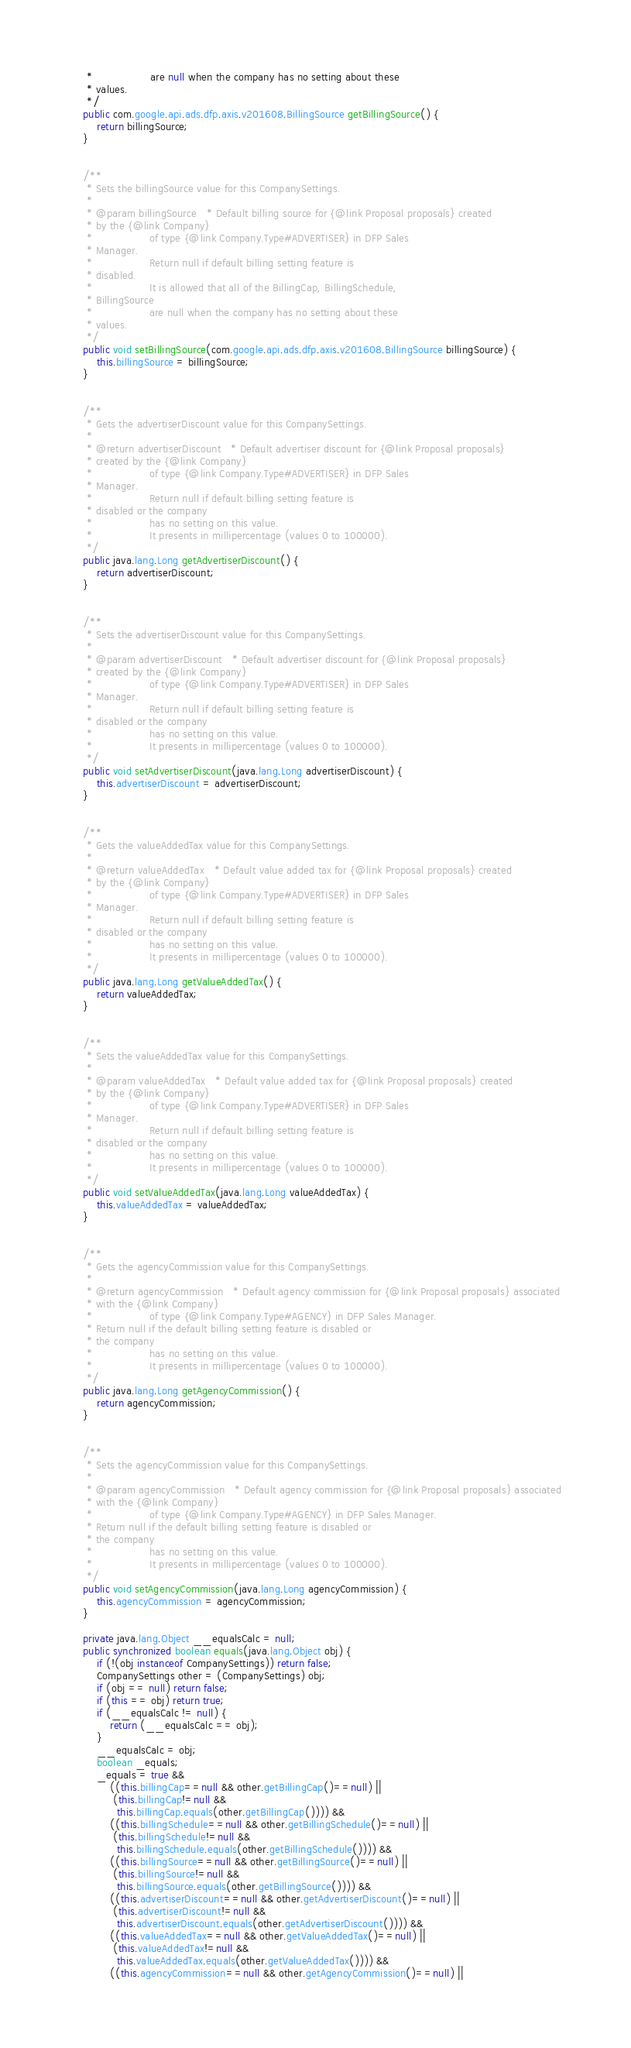Convert code to text. <code><loc_0><loc_0><loc_500><loc_500><_Java_>     *                 are null when the company has no setting about these
     * values.
     */
    public com.google.api.ads.dfp.axis.v201608.BillingSource getBillingSource() {
        return billingSource;
    }


    /**
     * Sets the billingSource value for this CompanySettings.
     * 
     * @param billingSource   * Default billing source for {@link Proposal proposals} created
     * by the {@link Company}
     *                 of type {@link Company.Type#ADVERTISER} in DFP Sales
     * Manager.
     *                 Return null if default billing setting feature is
     * disabled.
     *                 It is allowed that all of the BillingCap, BillingSchedule,
     * BillingSource
     *                 are null when the company has no setting about these
     * values.
     */
    public void setBillingSource(com.google.api.ads.dfp.axis.v201608.BillingSource billingSource) {
        this.billingSource = billingSource;
    }


    /**
     * Gets the advertiserDiscount value for this CompanySettings.
     * 
     * @return advertiserDiscount   * Default advertiser discount for {@link Proposal proposals}
     * created by the {@link Company}
     *                 of type {@link Company.Type#ADVERTISER} in DFP Sales
     * Manager.
     *                 Return null if default billing setting feature is
     * disabled or the company
     *                 has no setting on this value.
     *                 It presents in millipercentage (values 0 to 100000).
     */
    public java.lang.Long getAdvertiserDiscount() {
        return advertiserDiscount;
    }


    /**
     * Sets the advertiserDiscount value for this CompanySettings.
     * 
     * @param advertiserDiscount   * Default advertiser discount for {@link Proposal proposals}
     * created by the {@link Company}
     *                 of type {@link Company.Type#ADVERTISER} in DFP Sales
     * Manager.
     *                 Return null if default billing setting feature is
     * disabled or the company
     *                 has no setting on this value.
     *                 It presents in millipercentage (values 0 to 100000).
     */
    public void setAdvertiserDiscount(java.lang.Long advertiserDiscount) {
        this.advertiserDiscount = advertiserDiscount;
    }


    /**
     * Gets the valueAddedTax value for this CompanySettings.
     * 
     * @return valueAddedTax   * Default value added tax for {@link Proposal proposals} created
     * by the {@link Company}
     *                 of type {@link Company.Type#ADVERTISER} in DFP Sales
     * Manager.
     *                 Return null if default billing setting feature is
     * disabled or the company
     *                 has no setting on this value.
     *                 It presents in millipercentage (values 0 to 100000).
     */
    public java.lang.Long getValueAddedTax() {
        return valueAddedTax;
    }


    /**
     * Sets the valueAddedTax value for this CompanySettings.
     * 
     * @param valueAddedTax   * Default value added tax for {@link Proposal proposals} created
     * by the {@link Company}
     *                 of type {@link Company.Type#ADVERTISER} in DFP Sales
     * Manager.
     *                 Return null if default billing setting feature is
     * disabled or the company
     *                 has no setting on this value.
     *                 It presents in millipercentage (values 0 to 100000).
     */
    public void setValueAddedTax(java.lang.Long valueAddedTax) {
        this.valueAddedTax = valueAddedTax;
    }


    /**
     * Gets the agencyCommission value for this CompanySettings.
     * 
     * @return agencyCommission   * Default agency commission for {@link Proposal proposals} associated
     * with the {@link Company}
     *                 of type {@link Company.Type#AGENCY} in DFP Sales Manager.
     * Return null if the default billing setting feature is disabled or
     * the company
     *                 has no setting on this value.
     *                 It presents in millipercentage (values 0 to 100000).
     */
    public java.lang.Long getAgencyCommission() {
        return agencyCommission;
    }


    /**
     * Sets the agencyCommission value for this CompanySettings.
     * 
     * @param agencyCommission   * Default agency commission for {@link Proposal proposals} associated
     * with the {@link Company}
     *                 of type {@link Company.Type#AGENCY} in DFP Sales Manager.
     * Return null if the default billing setting feature is disabled or
     * the company
     *                 has no setting on this value.
     *                 It presents in millipercentage (values 0 to 100000).
     */
    public void setAgencyCommission(java.lang.Long agencyCommission) {
        this.agencyCommission = agencyCommission;
    }

    private java.lang.Object __equalsCalc = null;
    public synchronized boolean equals(java.lang.Object obj) {
        if (!(obj instanceof CompanySettings)) return false;
        CompanySettings other = (CompanySettings) obj;
        if (obj == null) return false;
        if (this == obj) return true;
        if (__equalsCalc != null) {
            return (__equalsCalc == obj);
        }
        __equalsCalc = obj;
        boolean _equals;
        _equals = true && 
            ((this.billingCap==null && other.getBillingCap()==null) || 
             (this.billingCap!=null &&
              this.billingCap.equals(other.getBillingCap()))) &&
            ((this.billingSchedule==null && other.getBillingSchedule()==null) || 
             (this.billingSchedule!=null &&
              this.billingSchedule.equals(other.getBillingSchedule()))) &&
            ((this.billingSource==null && other.getBillingSource()==null) || 
             (this.billingSource!=null &&
              this.billingSource.equals(other.getBillingSource()))) &&
            ((this.advertiserDiscount==null && other.getAdvertiserDiscount()==null) || 
             (this.advertiserDiscount!=null &&
              this.advertiserDiscount.equals(other.getAdvertiserDiscount()))) &&
            ((this.valueAddedTax==null && other.getValueAddedTax()==null) || 
             (this.valueAddedTax!=null &&
              this.valueAddedTax.equals(other.getValueAddedTax()))) &&
            ((this.agencyCommission==null && other.getAgencyCommission()==null) || </code> 